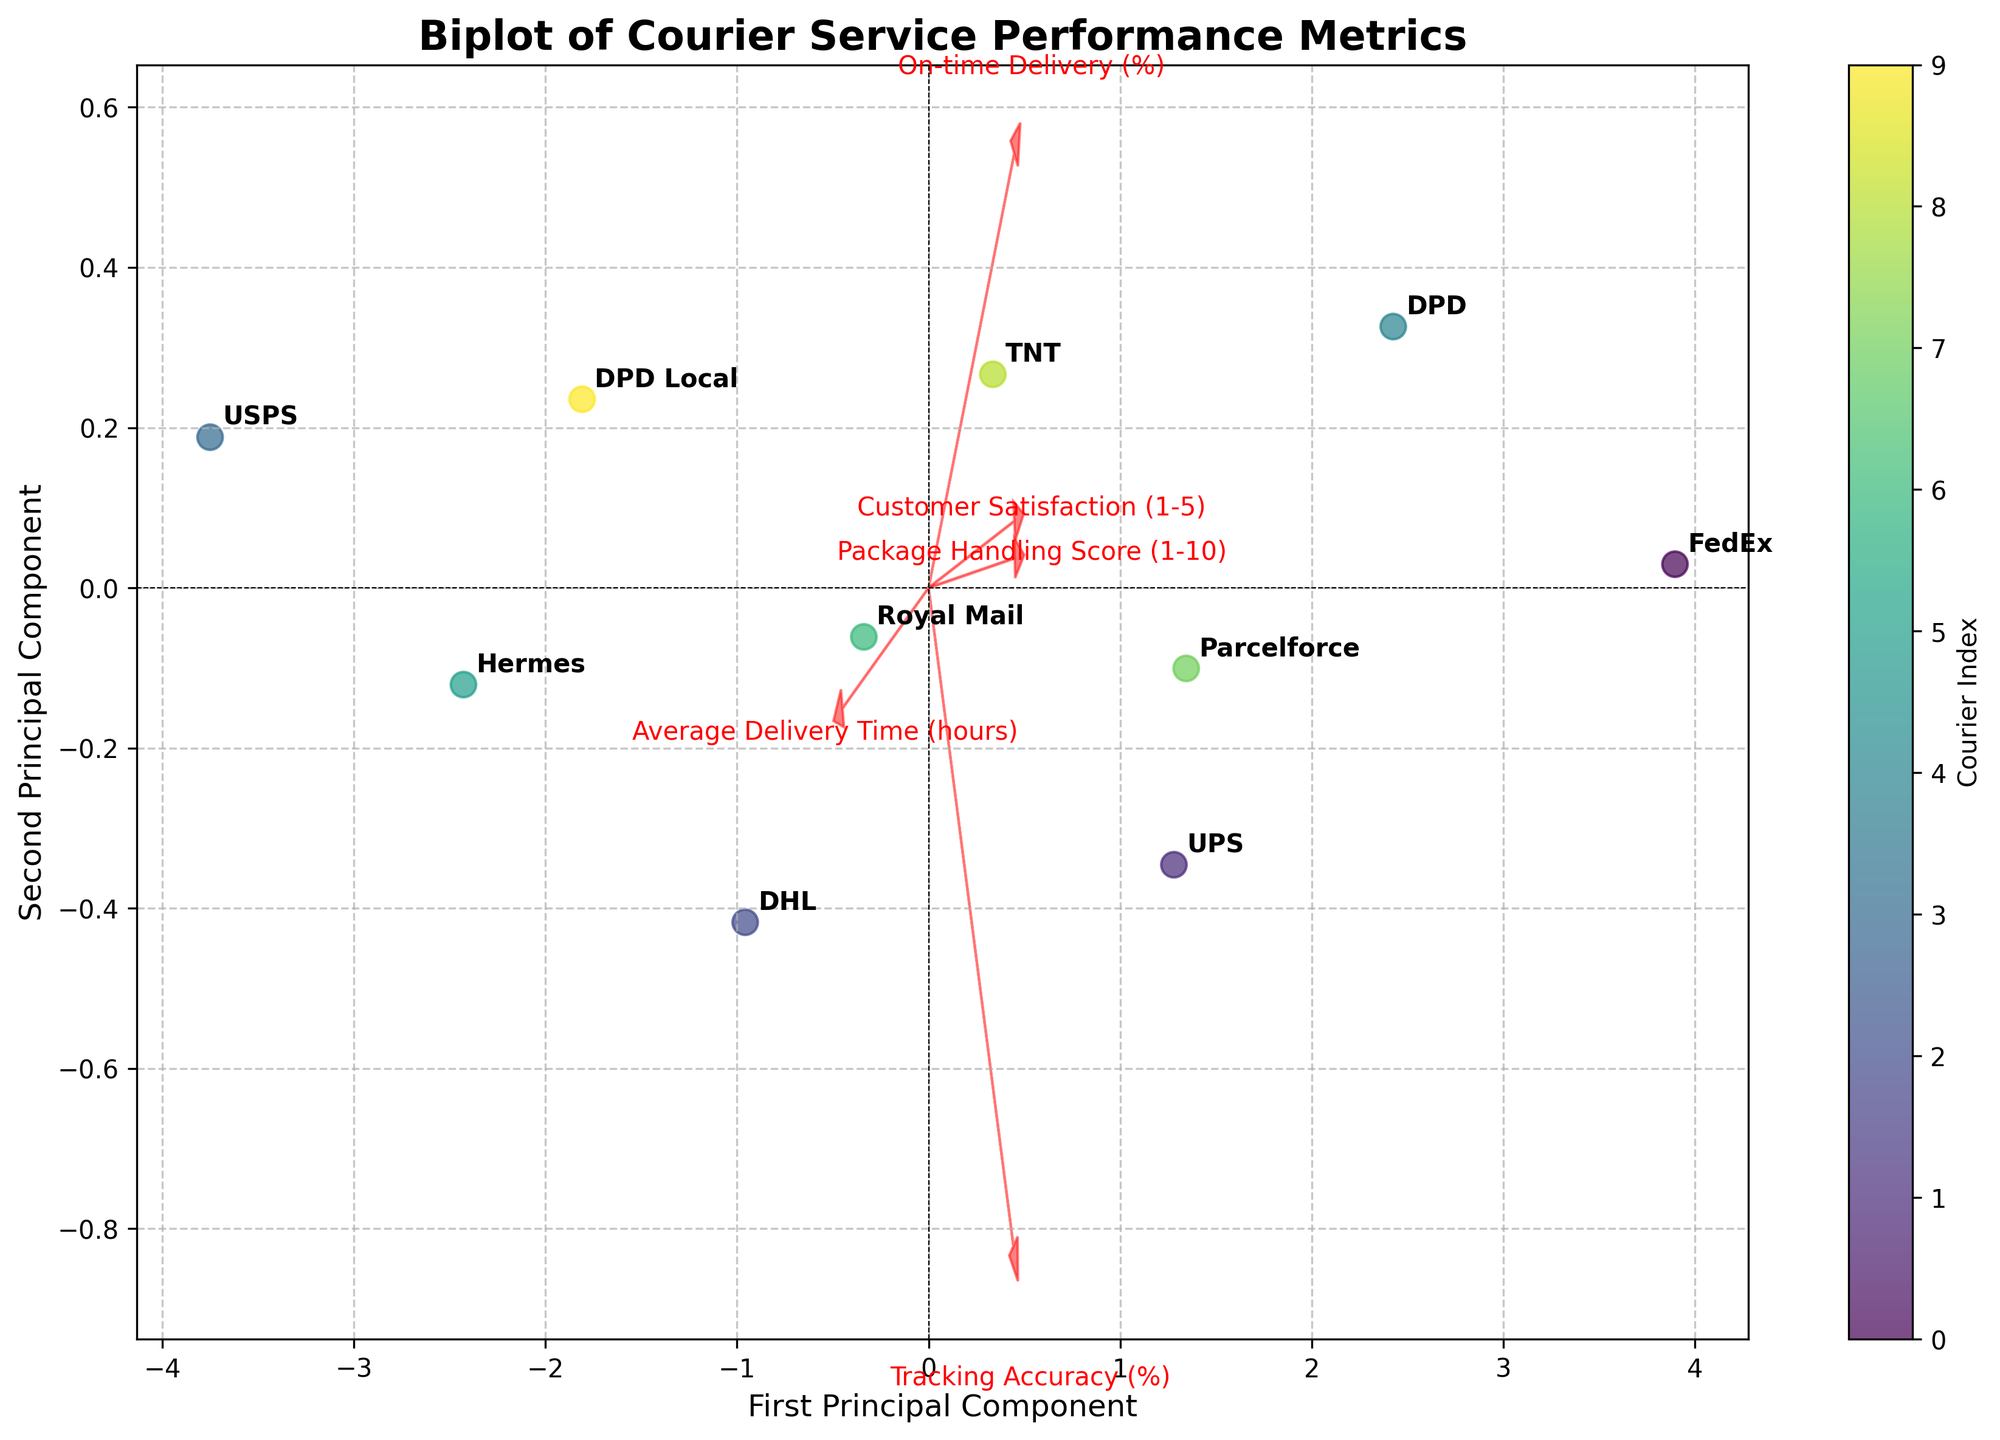Which courier has the highest on-time delivery percentage? The point that is farthest along the direction of the 'On-time Delivery (%)' arrow (assuming it is labeled on the biplot) indicates the highest on-time delivery percentage. By visually inspecting, we can determine the courier.
Answer: FedEx Which two couriers have the most similar performance according to the first two principal components? By observing the positions of the couriers on the biplot, the two couriers closest to each other in space according to the first and second principal components have the most similar performance overall.
Answer: UPS and Parcelforce Is there a courier service that stands out in terms of customer satisfaction? Look for the courier point that is farthest along the direction of the 'Customer Satisfaction (1-5)' arrow on the biplot. This indicates it scores highest on customer satisfaction.
Answer: FedEx Which performance metric seems to contribute most significantly to the first principal component? The length of the arrows (vectors) representing each performance metric suggests their contribution. The feature vector with the longest arrow in the direction of the first principal component indicates the highest contribution.
Answer: On-time Delivery (%) Is there a negative relationship between 'Average Delivery Time' and 'Package Handling Score'? On a biplot, if the arrows (vectors) for these metrics point in nearly opposite directions, then there is a negative relationship between these two performance metrics.
Answer: Yes Which courier has the closest tracking accuracy to ‘DHL’? Find the point representing DHL and then identify the closest point in terms of the 'Tracking Accuracy (%)' direction on the biplot.
Answer: Royal Mail What can you infer about the relationship between 'Customer Satisfaction' and 'Tracking Accuracy'? Analyze the angle between the arrows (vectors) for 'Customer Satisfaction (1-5)' and 'Tracking Accuracy (%)'; if they are close to 90 degrees, then these features are relatively uncorrelated.
Answer: Relatively uncorrelated How many principal components are shown in the biplot? A biplot typically shows data points in the space formed by the first two principal components, so this figure uses two principal components to represent the data.
Answer: Two Which courier service has the longest average delivery time, according to the biplot? The point that is farthest along the direction of the 'Average Delivery Time (hours)' arrow indicates the courier with the longest delivery time.
Answer: USPS Are on-time delivery and package handling score closely correlated? On the biplot, closely correlated features will have arrows (vectors) pointing in a similar direction. Check the direction of the 'On-time Delivery (%)' and 'Package Handling Score (1-10).'
Answer: Yes 